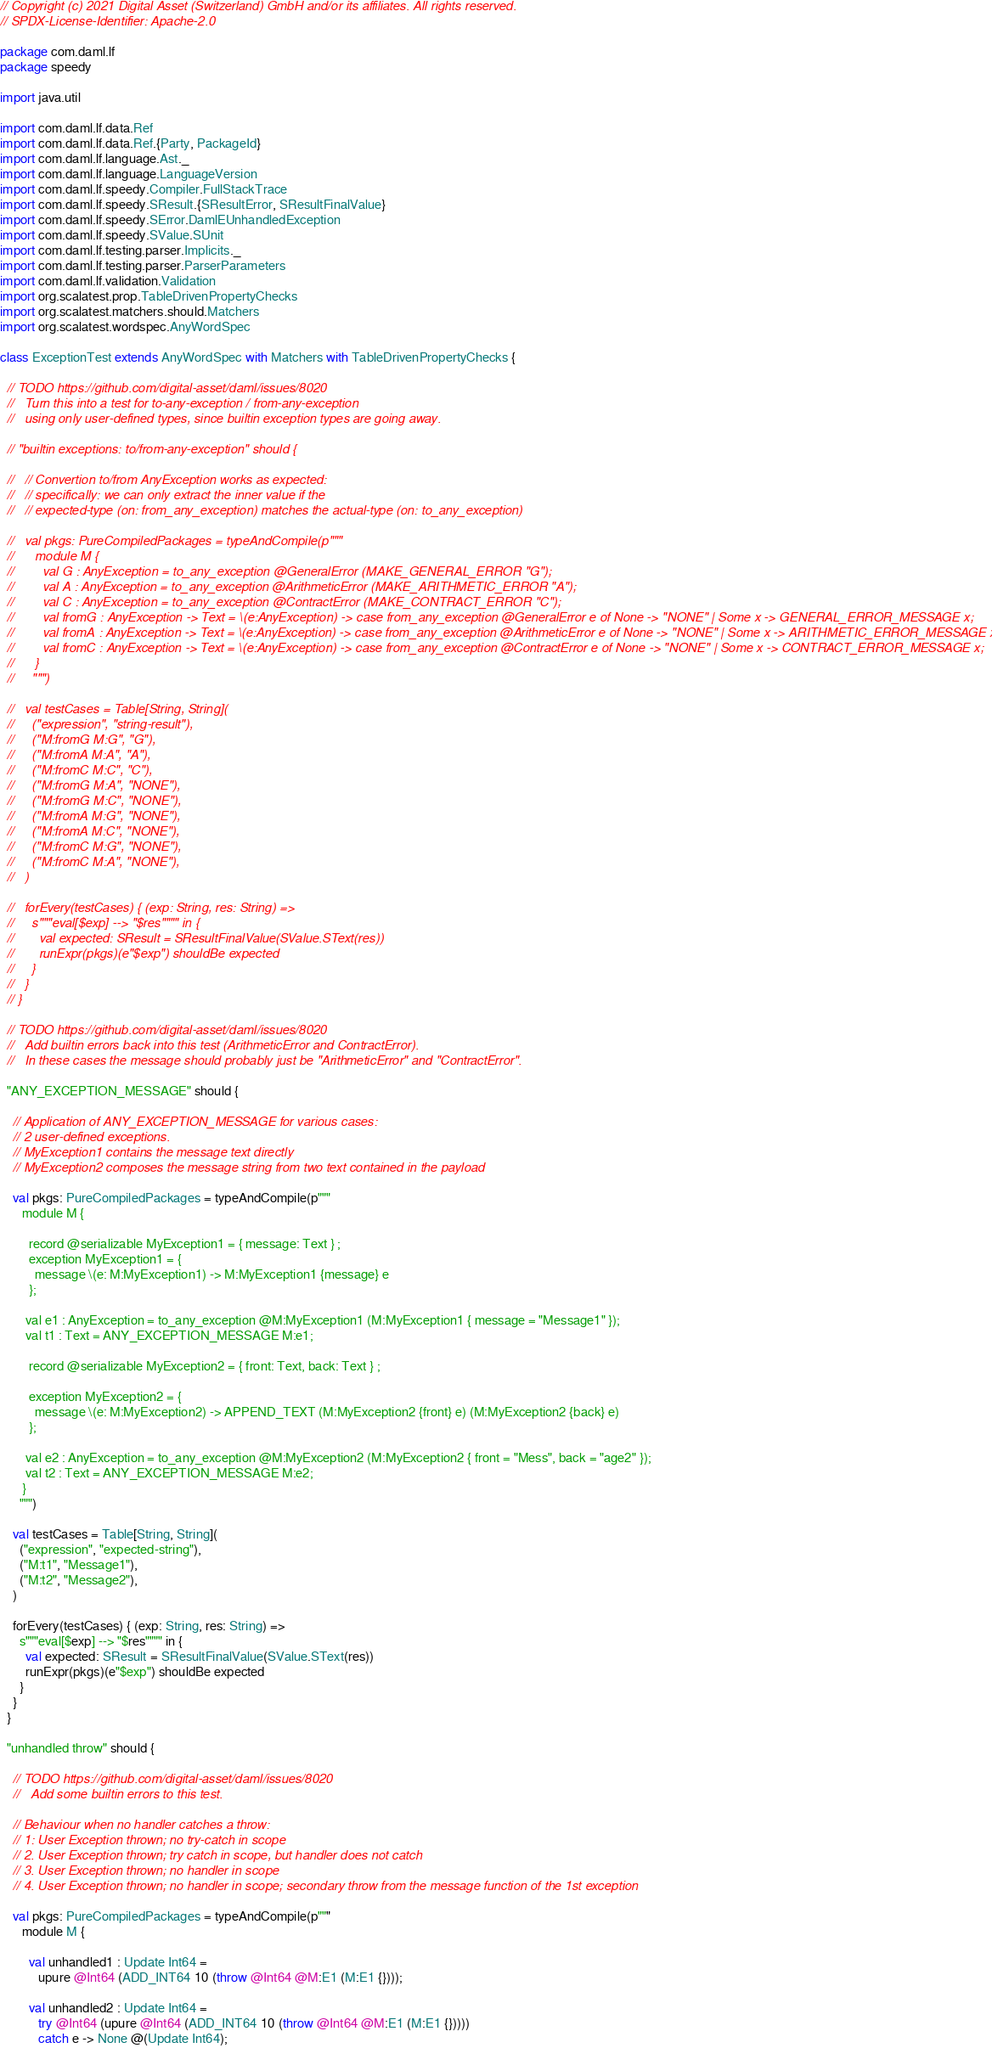Convert code to text. <code><loc_0><loc_0><loc_500><loc_500><_Scala_>// Copyright (c) 2021 Digital Asset (Switzerland) GmbH and/or its affiliates. All rights reserved.
// SPDX-License-Identifier: Apache-2.0

package com.daml.lf
package speedy

import java.util

import com.daml.lf.data.Ref
import com.daml.lf.data.Ref.{Party, PackageId}
import com.daml.lf.language.Ast._
import com.daml.lf.language.LanguageVersion
import com.daml.lf.speedy.Compiler.FullStackTrace
import com.daml.lf.speedy.SResult.{SResultError, SResultFinalValue}
import com.daml.lf.speedy.SError.DamlEUnhandledException
import com.daml.lf.speedy.SValue.SUnit
import com.daml.lf.testing.parser.Implicits._
import com.daml.lf.testing.parser.ParserParameters
import com.daml.lf.validation.Validation
import org.scalatest.prop.TableDrivenPropertyChecks
import org.scalatest.matchers.should.Matchers
import org.scalatest.wordspec.AnyWordSpec

class ExceptionTest extends AnyWordSpec with Matchers with TableDrivenPropertyChecks {

  // TODO https://github.com/digital-asset/daml/issues/8020
  //   Turn this into a test for to-any-exception / from-any-exception
  //   using only user-defined types, since builtin exception types are going away.

  // "builtin exceptions: to/from-any-exception" should {

  //   // Convertion to/from AnyException works as expected:
  //   // specifically: we can only extract the inner value if the
  //   // expected-type (on: from_any_exception) matches the actual-type (on: to_any_exception)

  //   val pkgs: PureCompiledPackages = typeAndCompile(p"""
  //      module M {
  //        val G : AnyException = to_any_exception @GeneralError (MAKE_GENERAL_ERROR "G");
  //        val A : AnyException = to_any_exception @ArithmeticError (MAKE_ARITHMETIC_ERROR "A");
  //        val C : AnyException = to_any_exception @ContractError (MAKE_CONTRACT_ERROR "C");
  //        val fromG : AnyException -> Text = \(e:AnyException) -> case from_any_exception @GeneralError e of None -> "NONE" | Some x -> GENERAL_ERROR_MESSAGE x;
  //        val fromA : AnyException -> Text = \(e:AnyException) -> case from_any_exception @ArithmeticError e of None -> "NONE" | Some x -> ARITHMETIC_ERROR_MESSAGE x;
  //        val fromC : AnyException -> Text = \(e:AnyException) -> case from_any_exception @ContractError e of None -> "NONE" | Some x -> CONTRACT_ERROR_MESSAGE x;
  //      }
  //     """)

  //   val testCases = Table[String, String](
  //     ("expression", "string-result"),
  //     ("M:fromG M:G", "G"),
  //     ("M:fromA M:A", "A"),
  //     ("M:fromC M:C", "C"),
  //     ("M:fromG M:A", "NONE"),
  //     ("M:fromG M:C", "NONE"),
  //     ("M:fromA M:G", "NONE"),
  //     ("M:fromA M:C", "NONE"),
  //     ("M:fromC M:G", "NONE"),
  //     ("M:fromC M:A", "NONE"),
  //   )

  //   forEvery(testCases) { (exp: String, res: String) =>
  //     s"""eval[$exp] --> "$res"""" in {
  //       val expected: SResult = SResultFinalValue(SValue.SText(res))
  //       runExpr(pkgs)(e"$exp") shouldBe expected
  //     }
  //   }
  // }

  // TODO https://github.com/digital-asset/daml/issues/8020
  //   Add builtin errors back into this test (ArithmeticError and ContractError).
  //   In these cases the message should probably just be "ArithmeticError" and "ContractError".

  "ANY_EXCEPTION_MESSAGE" should {

    // Application of ANY_EXCEPTION_MESSAGE for various cases:
    // 2 user-defined exceptions.
    // MyException1 contains the message text directly
    // MyException2 composes the message string from two text contained in the payload

    val pkgs: PureCompiledPackages = typeAndCompile(p"""
       module M {

         record @serializable MyException1 = { message: Text } ;
         exception MyException1 = {
           message \(e: M:MyException1) -> M:MyException1 {message} e
         };

        val e1 : AnyException = to_any_exception @M:MyException1 (M:MyException1 { message = "Message1" });
        val t1 : Text = ANY_EXCEPTION_MESSAGE M:e1;

         record @serializable MyException2 = { front: Text, back: Text } ;

         exception MyException2 = {
           message \(e: M:MyException2) -> APPEND_TEXT (M:MyException2 {front} e) (M:MyException2 {back} e)
         };

        val e2 : AnyException = to_any_exception @M:MyException2 (M:MyException2 { front = "Mess", back = "age2" });
        val t2 : Text = ANY_EXCEPTION_MESSAGE M:e2;
       }
      """)

    val testCases = Table[String, String](
      ("expression", "expected-string"),
      ("M:t1", "Message1"),
      ("M:t2", "Message2"),
    )

    forEvery(testCases) { (exp: String, res: String) =>
      s"""eval[$exp] --> "$res"""" in {
        val expected: SResult = SResultFinalValue(SValue.SText(res))
        runExpr(pkgs)(e"$exp") shouldBe expected
      }
    }
  }

  "unhandled throw" should {

    // TODO https://github.com/digital-asset/daml/issues/8020
    //   Add some builtin errors to this test.

    // Behaviour when no handler catches a throw:
    // 1: User Exception thrown; no try-catch in scope
    // 2. User Exception thrown; try catch in scope, but handler does not catch
    // 3. User Exception thrown; no handler in scope
    // 4. User Exception thrown; no handler in scope; secondary throw from the message function of the 1st exception

    val pkgs: PureCompiledPackages = typeAndCompile(p"""
       module M {

         val unhandled1 : Update Int64 =
            upure @Int64 (ADD_INT64 10 (throw @Int64 @M:E1 (M:E1 {})));

         val unhandled2 : Update Int64 =
            try @Int64 (upure @Int64 (ADD_INT64 10 (throw @Int64 @M:E1 (M:E1 {}))))
            catch e -> None @(Update Int64);
</code> 